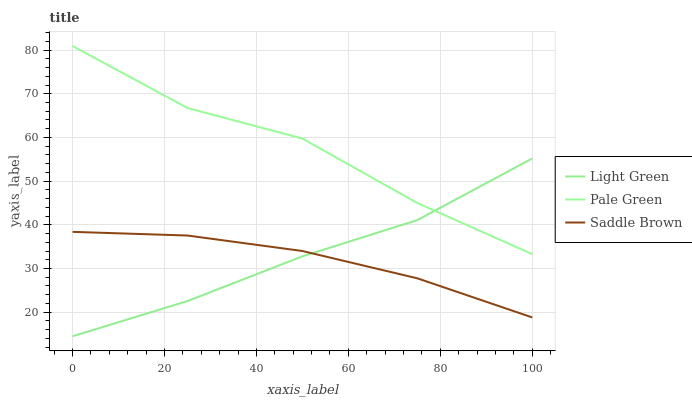Does Saddle Brown have the minimum area under the curve?
Answer yes or no. Yes. Does Pale Green have the maximum area under the curve?
Answer yes or no. Yes. Does Light Green have the minimum area under the curve?
Answer yes or no. No. Does Light Green have the maximum area under the curve?
Answer yes or no. No. Is Saddle Brown the smoothest?
Answer yes or no. Yes. Is Pale Green the roughest?
Answer yes or no. Yes. Is Light Green the smoothest?
Answer yes or no. No. Is Light Green the roughest?
Answer yes or no. No. Does Saddle Brown have the lowest value?
Answer yes or no. No. Does Pale Green have the highest value?
Answer yes or no. Yes. Does Light Green have the highest value?
Answer yes or no. No. Is Saddle Brown less than Pale Green?
Answer yes or no. Yes. Is Pale Green greater than Saddle Brown?
Answer yes or no. Yes. Does Saddle Brown intersect Pale Green?
Answer yes or no. No. 